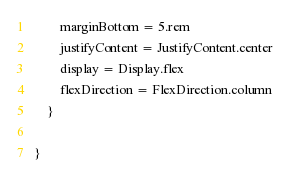<code> <loc_0><loc_0><loc_500><loc_500><_Kotlin_>        marginBottom = 5.rem
        justifyContent = JustifyContent.center
        display = Display.flex
        flexDirection = FlexDirection.column
    }

}</code> 